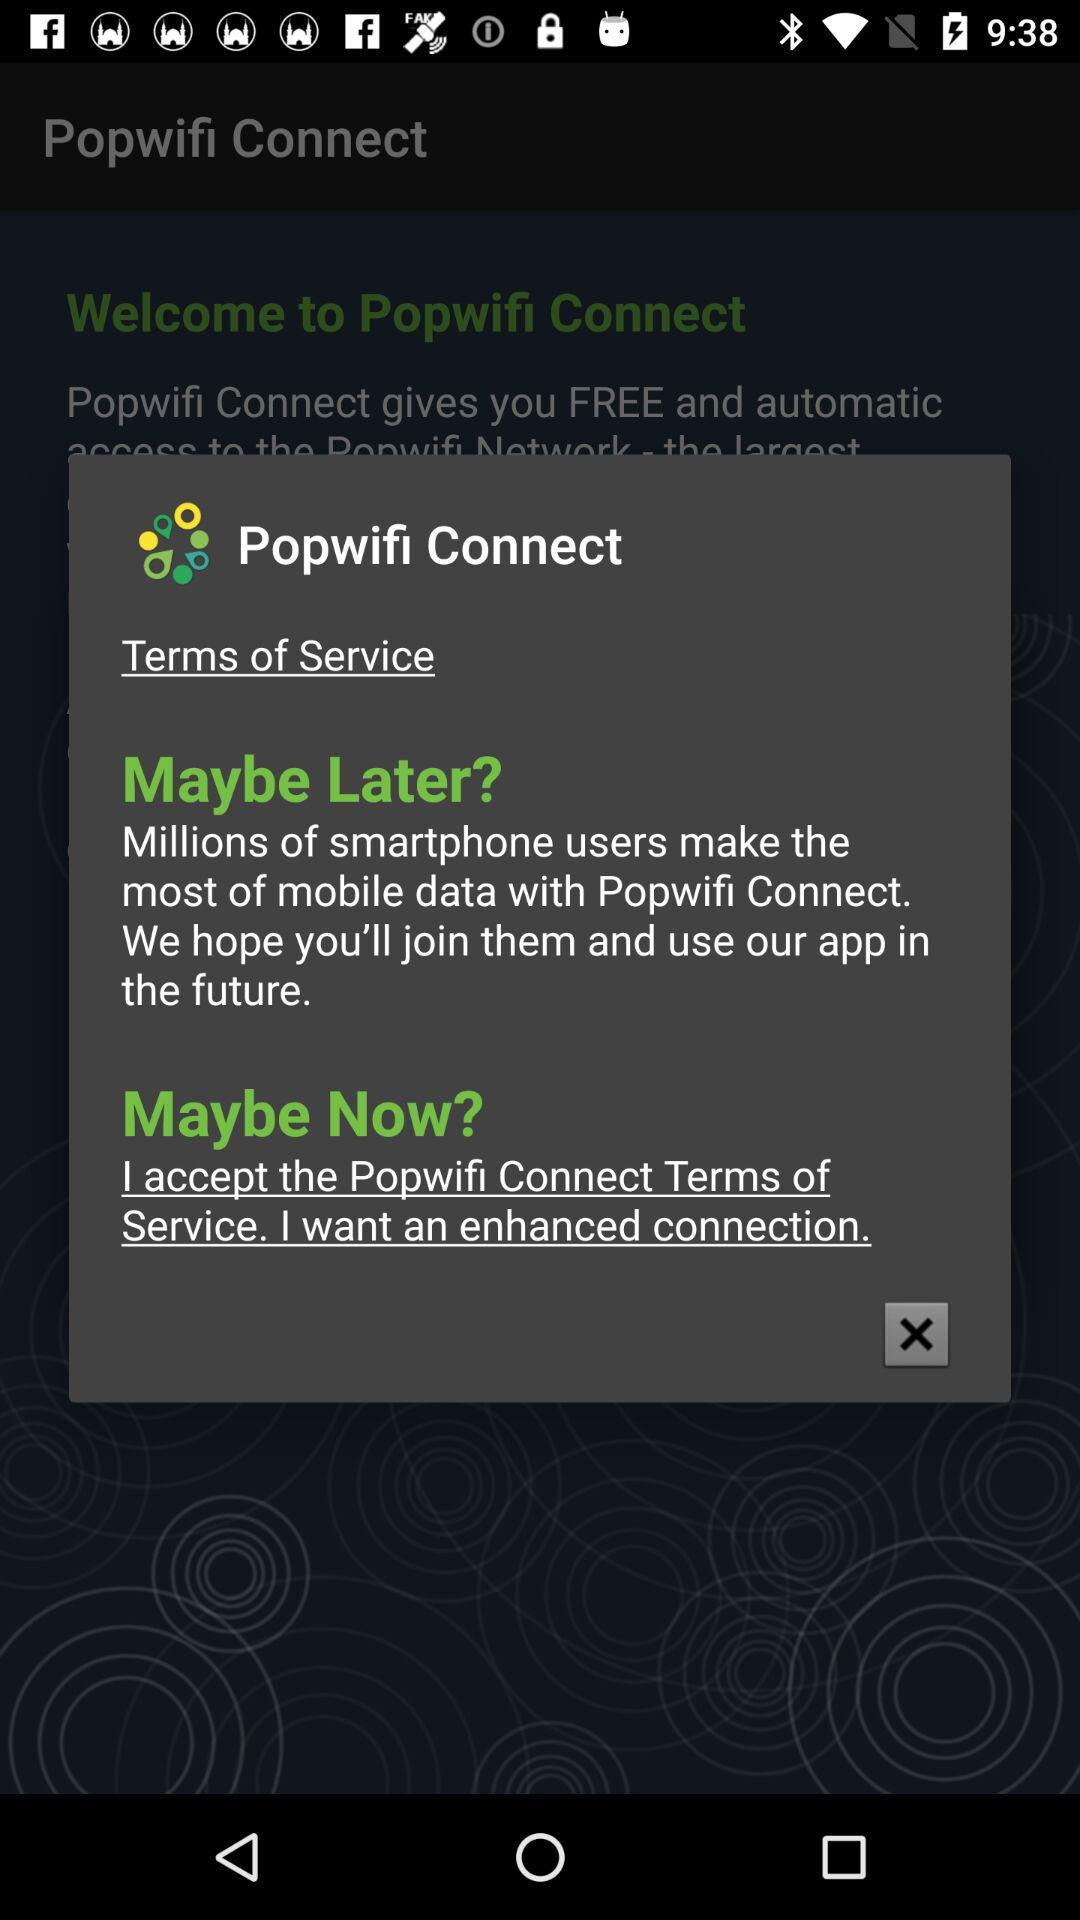Has the user agreed to the terms of service?
When the provided information is insufficient, respond with <no answer>. <no answer> 